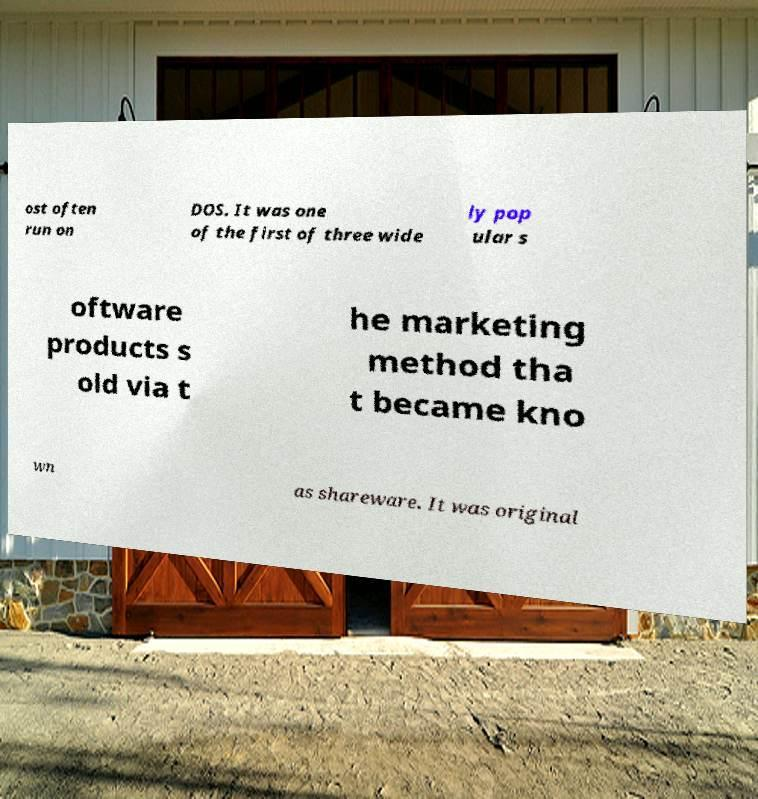What messages or text are displayed in this image? I need them in a readable, typed format. ost often run on DOS. It was one of the first of three wide ly pop ular s oftware products s old via t he marketing method tha t became kno wn as shareware. It was original 